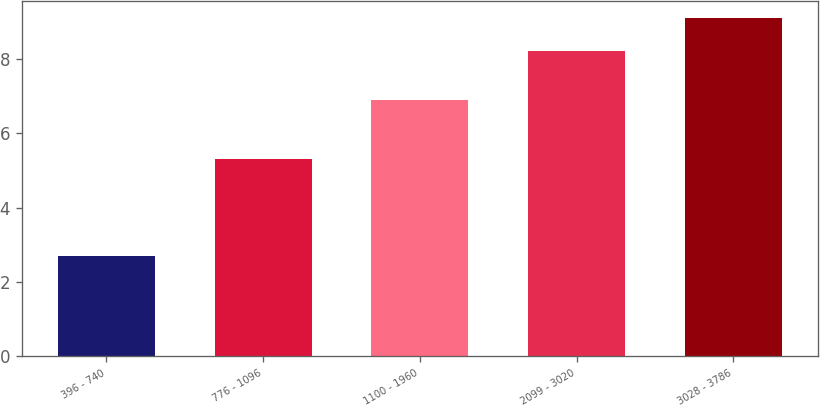<chart> <loc_0><loc_0><loc_500><loc_500><bar_chart><fcel>396 - 740<fcel>776 - 1096<fcel>1100 - 1960<fcel>2099 - 3020<fcel>3028 - 3786<nl><fcel>2.7<fcel>5.3<fcel>6.9<fcel>8.2<fcel>9.1<nl></chart> 